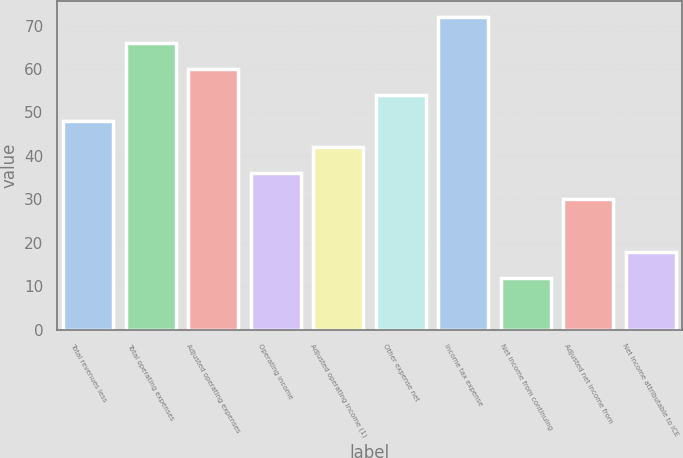Convert chart. <chart><loc_0><loc_0><loc_500><loc_500><bar_chart><fcel>Total revenues less<fcel>Total operating expenses<fcel>Adjusted operating expenses<fcel>Operating income<fcel>Adjusted operating income (1)<fcel>Other expense net<fcel>Income tax expense<fcel>Net income from continuing<fcel>Adjusted net income from<fcel>Net income attributable to ICE<nl><fcel>48<fcel>66<fcel>60<fcel>36<fcel>42<fcel>54<fcel>72<fcel>12<fcel>30<fcel>18<nl></chart> 